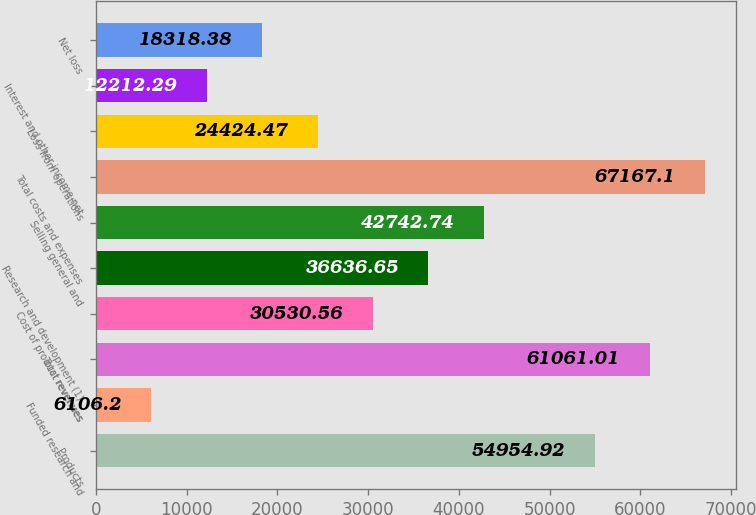Convert chart to OTSL. <chart><loc_0><loc_0><loc_500><loc_500><bar_chart><fcel>Products<fcel>Funded research and<fcel>Total revenues<fcel>Cost of product revenues<fcel>Research and development (1)<fcel>Selling general and<fcel>Total costs and expenses<fcel>Loss from operations<fcel>Interest and other income net<fcel>Net loss<nl><fcel>54954.9<fcel>6106.2<fcel>61061<fcel>30530.6<fcel>36636.7<fcel>42742.7<fcel>67167.1<fcel>24424.5<fcel>12212.3<fcel>18318.4<nl></chart> 